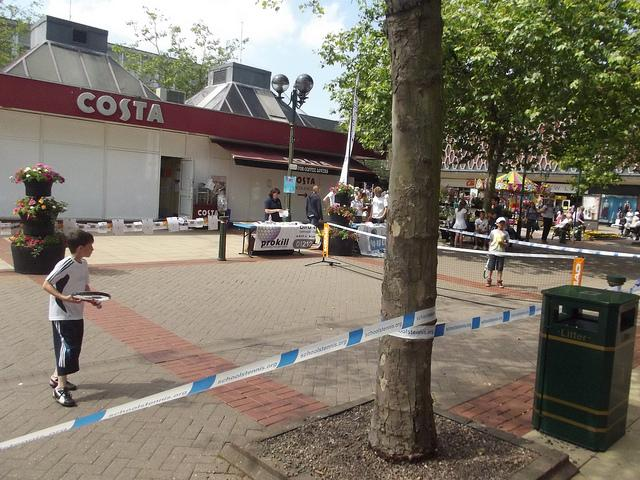What is the boy in the foreground doing? playing tennis 